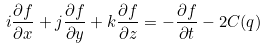Convert formula to latex. <formula><loc_0><loc_0><loc_500><loc_500>i \frac { \partial f } { \partial x } + j \frac { \partial f } { \partial y } + k \frac { \partial f } { \partial z } = - \frac { \partial f } { \partial t } - 2 C ( q )</formula> 